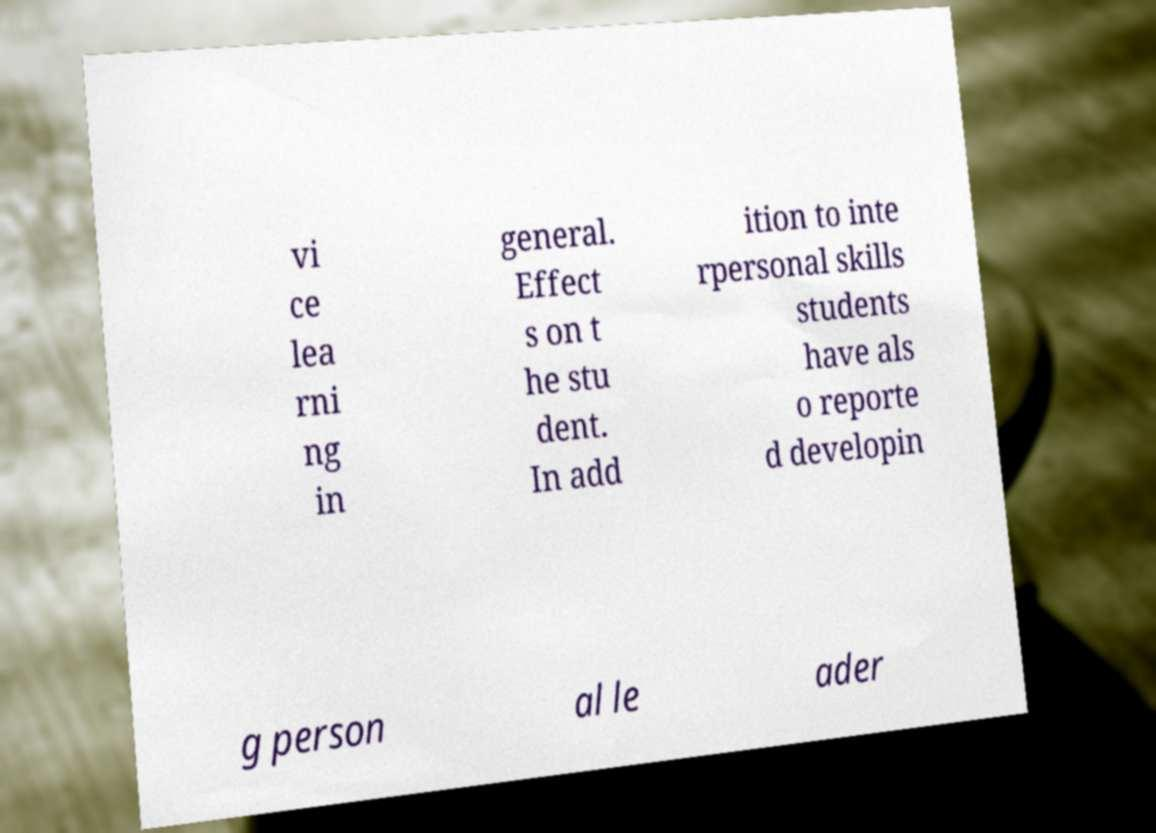There's text embedded in this image that I need extracted. Can you transcribe it verbatim? vi ce lea rni ng in general. Effect s on t he stu dent. In add ition to inte rpersonal skills students have als o reporte d developin g person al le ader 